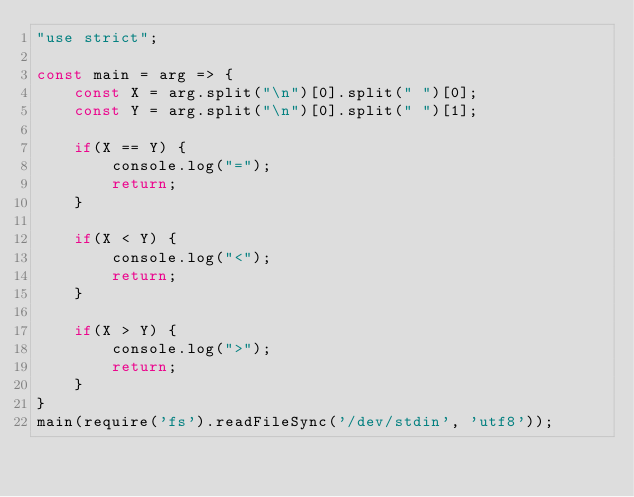<code> <loc_0><loc_0><loc_500><loc_500><_JavaScript_>"use strict";
    
const main = arg => {
    const X = arg.split("\n")[0].split(" ")[0];
    const Y = arg.split("\n")[0].split(" ")[1];
    
    if(X == Y) {
        console.log("=");
        return;
    }
    
    if(X < Y) {
        console.log("<");
        return;
    }
    
    if(X > Y) {
        console.log(">");
        return;
    }
}
main(require('fs').readFileSync('/dev/stdin', 'utf8'));</code> 